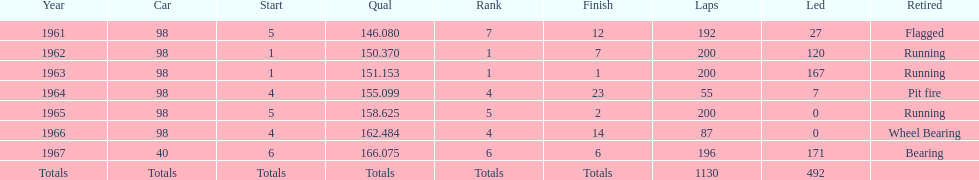Which car accomplished the peak standard? 40. 